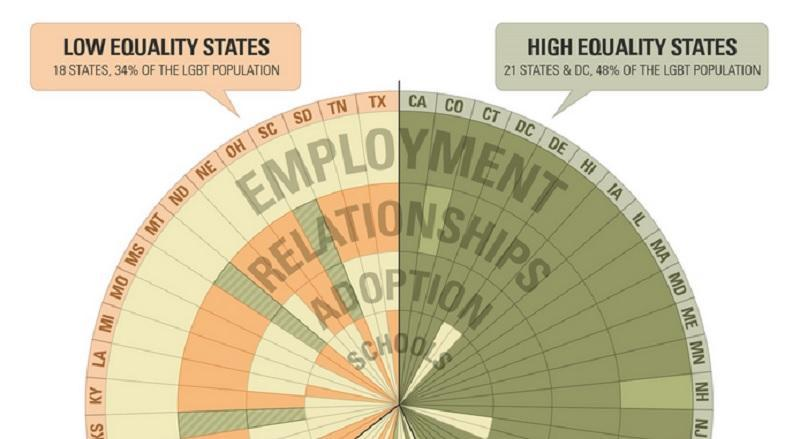Is DE a low equality state or a high equality state?
Answer the question with a short phrase. high equality state Is LA a low equality state or a high equality state? Low equality state How many states are low equality states? 18 How many states are high equality states? 21 Is TN a low equality state or a high equality state? Low equality state Is NJ a low equality state or a high equality state? High equality state What is the percentage of LGBT population in low equality states? 34% What is the percentage of LGBT population in high equality states? 48% 